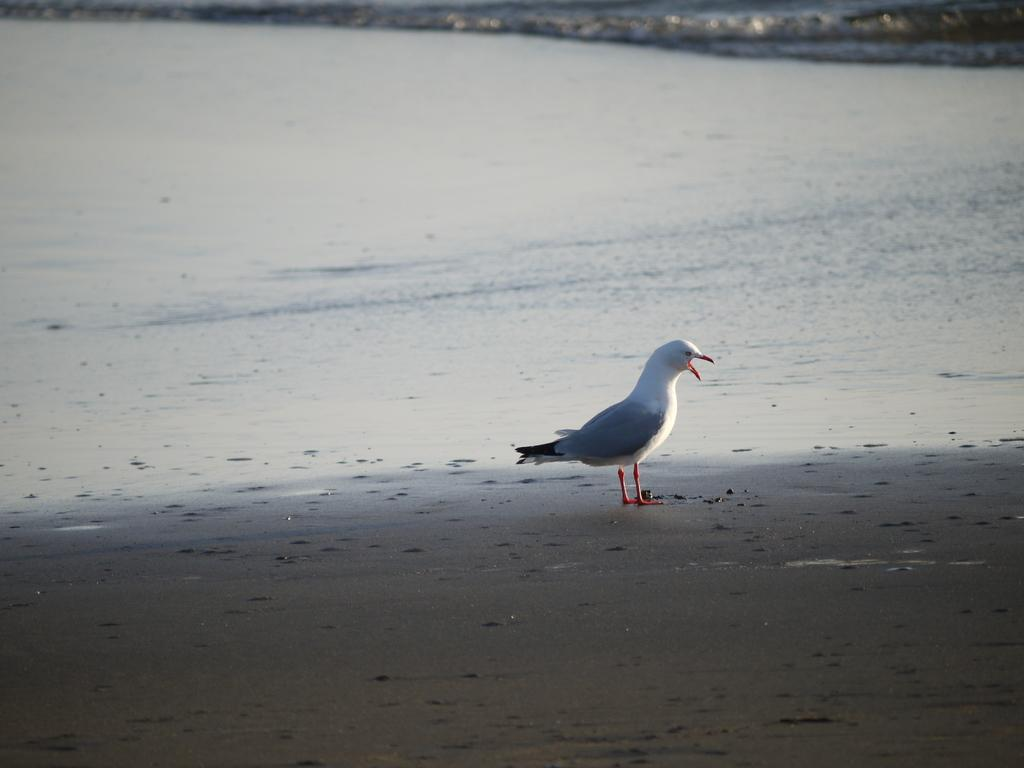What type of bird is in the image? There is a white pigeon in the image. Where is the pigeon located in relation to the sea? The pigeon is standing in front of the sea. How many rabbits can be seen in the picture? There are no rabbits present in the image; it features a white pigeon standing in front of the sea. Is there a woman in the image? There is no woman present in the image; it features a white pigeon standing in front of the sea. 